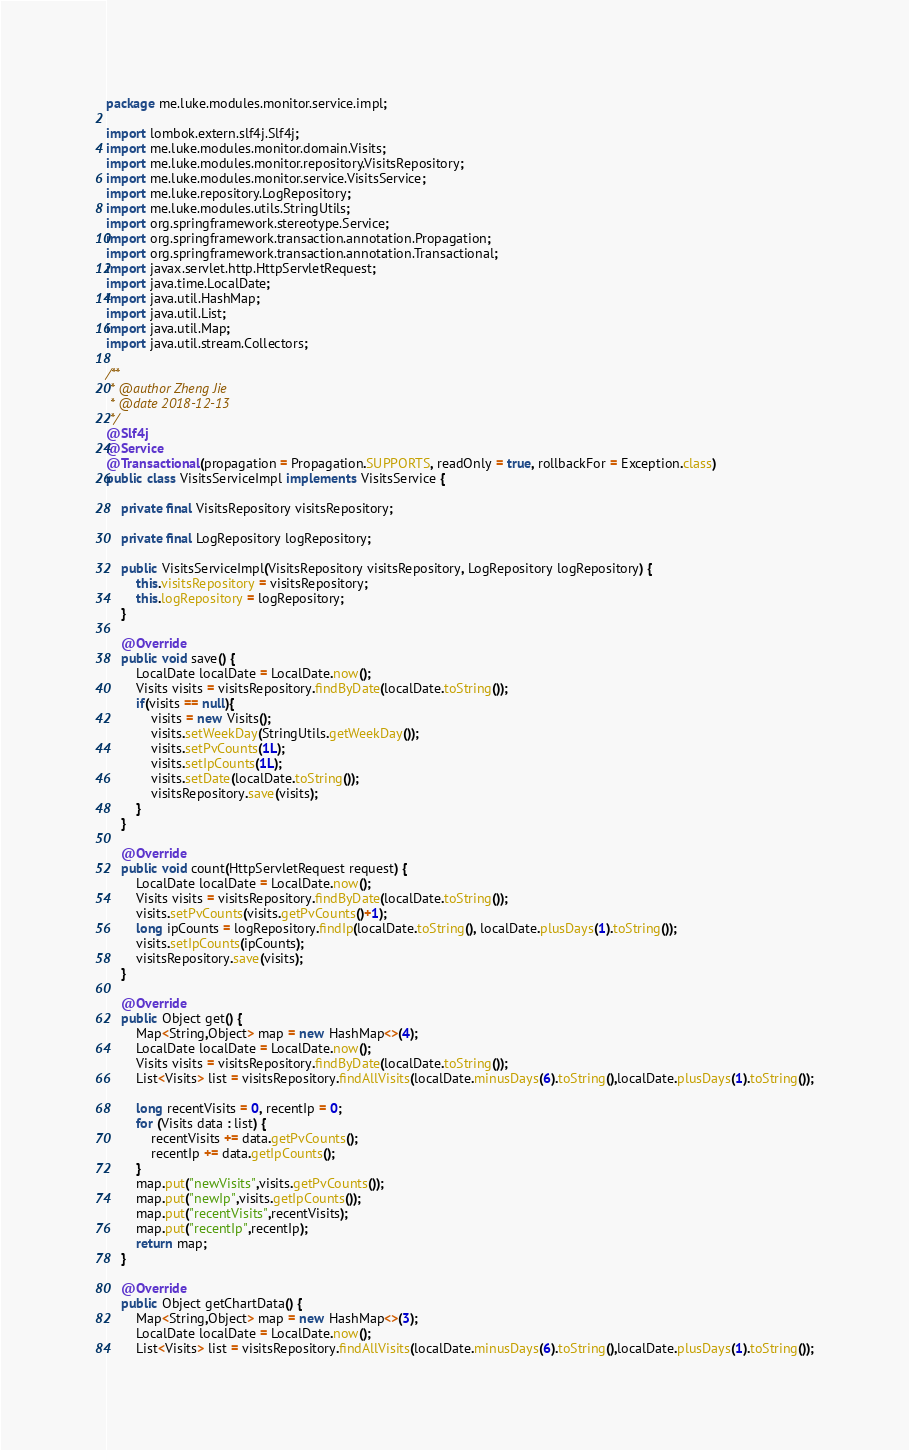<code> <loc_0><loc_0><loc_500><loc_500><_Java_>package me.luke.modules.monitor.service.impl;

import lombok.extern.slf4j.Slf4j;
import me.luke.modules.monitor.domain.Visits;
import me.luke.modules.monitor.repository.VisitsRepository;
import me.luke.modules.monitor.service.VisitsService;
import me.luke.repository.LogRepository;
import me.luke.modules.utils.StringUtils;
import org.springframework.stereotype.Service;
import org.springframework.transaction.annotation.Propagation;
import org.springframework.transaction.annotation.Transactional;
import javax.servlet.http.HttpServletRequest;
import java.time.LocalDate;
import java.util.HashMap;
import java.util.List;
import java.util.Map;
import java.util.stream.Collectors;

/**
 * @author Zheng Jie
 * @date 2018-12-13
 */
@Slf4j
@Service
@Transactional(propagation = Propagation.SUPPORTS, readOnly = true, rollbackFor = Exception.class)
public class VisitsServiceImpl implements VisitsService {

    private final VisitsRepository visitsRepository;

    private final LogRepository logRepository;

    public VisitsServiceImpl(VisitsRepository visitsRepository, LogRepository logRepository) {
        this.visitsRepository = visitsRepository;
        this.logRepository = logRepository;
    }

    @Override
    public void save() {
        LocalDate localDate = LocalDate.now();
        Visits visits = visitsRepository.findByDate(localDate.toString());
        if(visits == null){
            visits = new Visits();
            visits.setWeekDay(StringUtils.getWeekDay());
            visits.setPvCounts(1L);
            visits.setIpCounts(1L);
            visits.setDate(localDate.toString());
            visitsRepository.save(visits);
        }
    }

    @Override
    public void count(HttpServletRequest request) {
        LocalDate localDate = LocalDate.now();
        Visits visits = visitsRepository.findByDate(localDate.toString());
        visits.setPvCounts(visits.getPvCounts()+1);
        long ipCounts = logRepository.findIp(localDate.toString(), localDate.plusDays(1).toString());
        visits.setIpCounts(ipCounts);
        visitsRepository.save(visits);
    }

    @Override
    public Object get() {
        Map<String,Object> map = new HashMap<>(4);
        LocalDate localDate = LocalDate.now();
        Visits visits = visitsRepository.findByDate(localDate.toString());
        List<Visits> list = visitsRepository.findAllVisits(localDate.minusDays(6).toString(),localDate.plusDays(1).toString());

        long recentVisits = 0, recentIp = 0;
        for (Visits data : list) {
            recentVisits += data.getPvCounts();
            recentIp += data.getIpCounts();
        }
        map.put("newVisits",visits.getPvCounts());
        map.put("newIp",visits.getIpCounts());
        map.put("recentVisits",recentVisits);
        map.put("recentIp",recentIp);
        return map;
    }

    @Override
    public Object getChartData() {
        Map<String,Object> map = new HashMap<>(3);
        LocalDate localDate = LocalDate.now();
        List<Visits> list = visitsRepository.findAllVisits(localDate.minusDays(6).toString(),localDate.plusDays(1).toString());</code> 